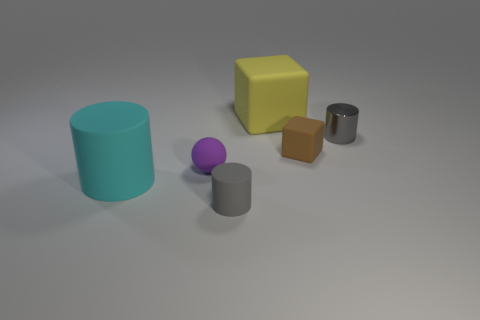What is the color of the small cylinder that is the same material as the small purple ball?
Provide a short and direct response. Gray. What number of cubes are either metal things or large cyan things?
Provide a succinct answer. 0. How many objects are either tiny things or cylinders that are behind the small block?
Your response must be concise. 4. Is there a large yellow thing?
Offer a terse response. Yes. How many large cylinders are the same color as the metal thing?
Offer a very short reply. 0. There is another tiny thing that is the same color as the small metallic thing; what material is it?
Your answer should be very brief. Rubber. How big is the gray cylinder behind the tiny object in front of the cyan cylinder?
Your response must be concise. Small. Are there any small brown blocks made of the same material as the cyan cylinder?
Offer a terse response. Yes. What material is the block that is the same size as the ball?
Offer a very short reply. Rubber. Is the color of the small object behind the brown thing the same as the cube behind the tiny metal cylinder?
Your answer should be very brief. No. 